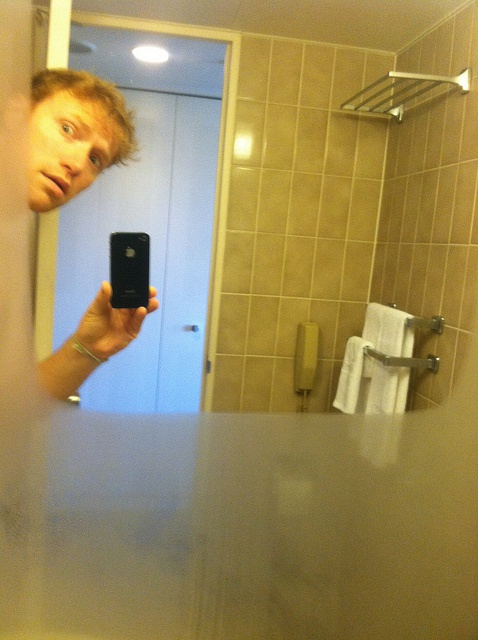Describe the objects in this image and their specific colors. I can see people in tan, olive, and gold tones and cell phone in tan, black, gray, and darkgreen tones in this image. 